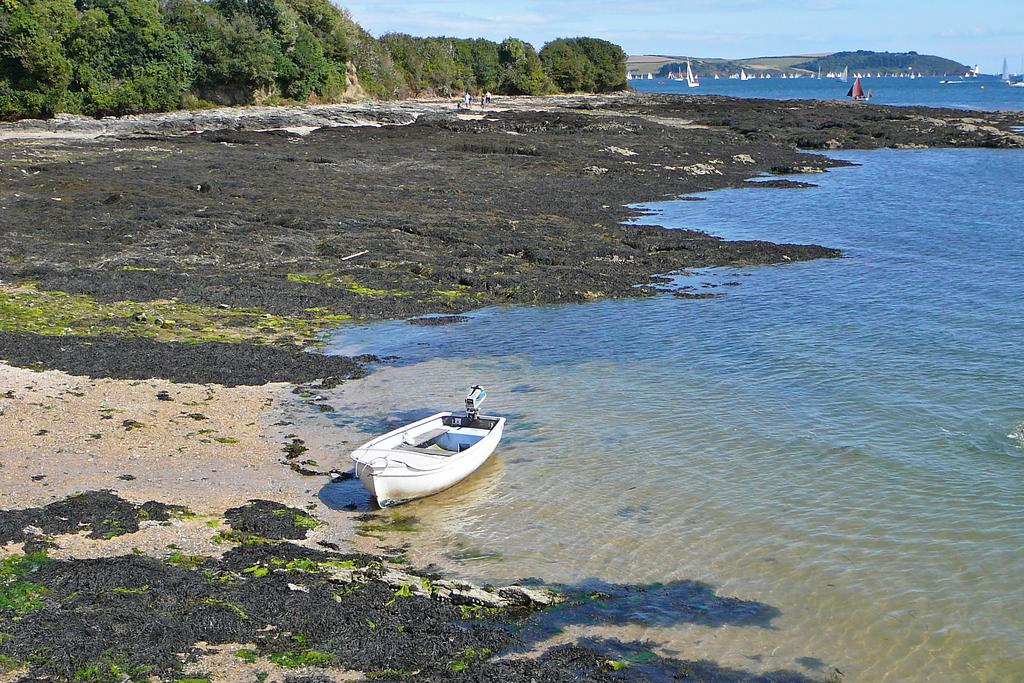What is the main feature of the image? The main feature of the image is water. What can be seen floating on the water? There are boats in the image. What type of natural environment is depicted in the image? The image includes trees and hills, which are part of a natural environment. What is visible above the water and natural elements? The sky is visible in the image. Where is the playground located in the image? There is no playground present in the image. What type of hole can be seen in the water in the image? There are no holes visible in the water in the image. 